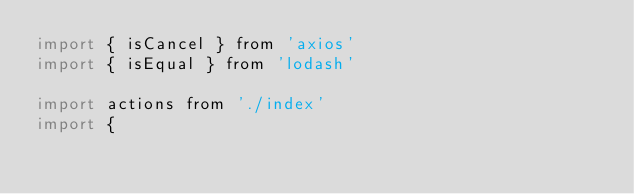Convert code to text. <code><loc_0><loc_0><loc_500><loc_500><_JavaScript_>import { isCancel } from 'axios'
import { isEqual } from 'lodash'

import actions from './index'
import {</code> 